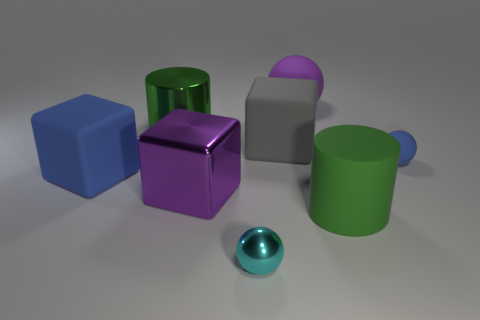Are there more cyan metal spheres on the left side of the cyan metallic object than blue spheres that are to the right of the big purple sphere? no 